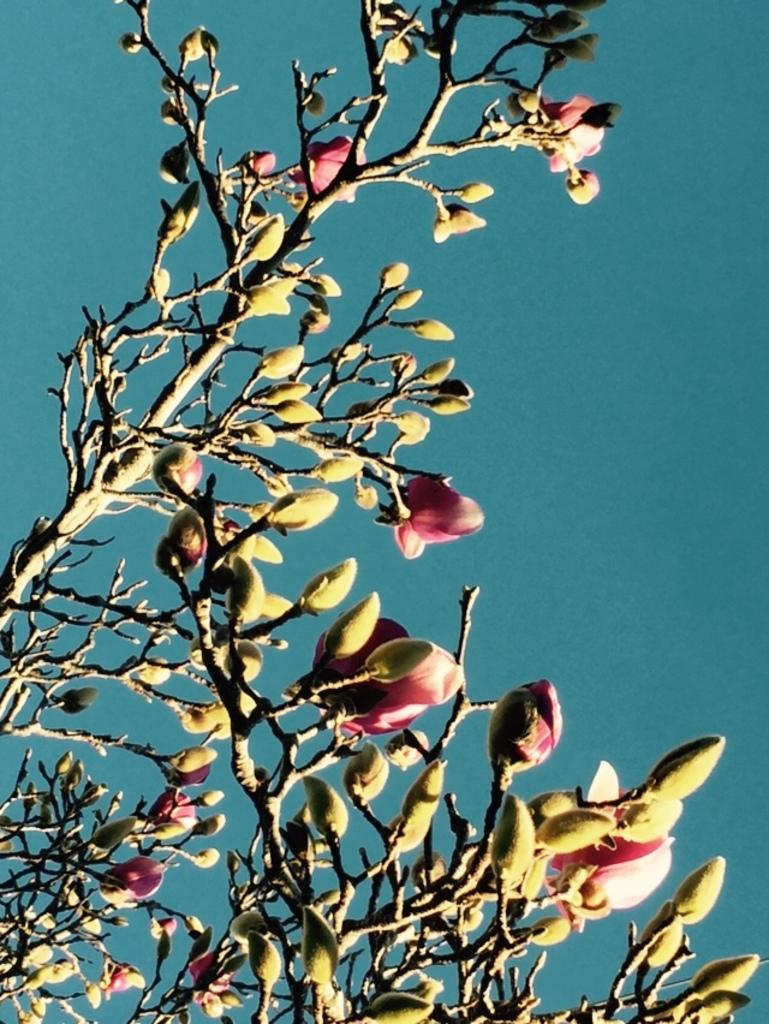What type of plant can be seen in the image? There is a tree in the image. What features can be observed on the tree? The tree has flowers and buds. What can be seen in the background of the image? There is sky visible in the background of the image. How many brothers are sitting on the truck in the image? There is no truck or brothers present in the image; it features a tree with flowers and buds against a sky background. 